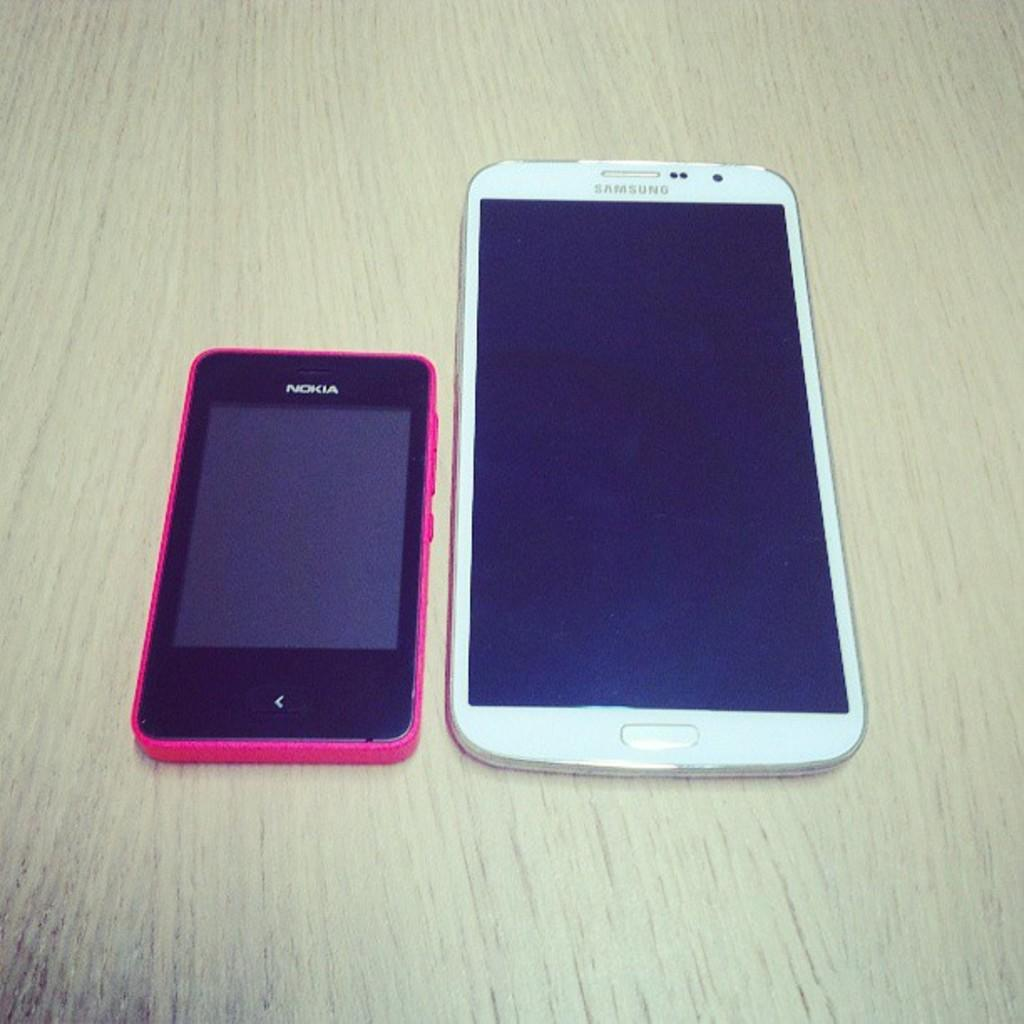<image>
Share a concise interpretation of the image provided. a small nokia phone next to a large white samsung phone 